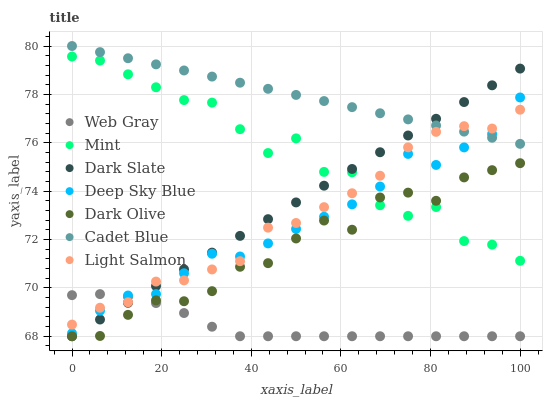Does Web Gray have the minimum area under the curve?
Answer yes or no. Yes. Does Cadet Blue have the maximum area under the curve?
Answer yes or no. Yes. Does Dark Olive have the minimum area under the curve?
Answer yes or no. No. Does Dark Olive have the maximum area under the curve?
Answer yes or no. No. Is Dark Slate the smoothest?
Answer yes or no. Yes. Is Mint the roughest?
Answer yes or no. Yes. Is Cadet Blue the smoothest?
Answer yes or no. No. Is Cadet Blue the roughest?
Answer yes or no. No. Does Dark Olive have the lowest value?
Answer yes or no. Yes. Does Cadet Blue have the lowest value?
Answer yes or no. No. Does Cadet Blue have the highest value?
Answer yes or no. Yes. Does Dark Olive have the highest value?
Answer yes or no. No. Is Dark Olive less than Deep Sky Blue?
Answer yes or no. Yes. Is Deep Sky Blue greater than Dark Olive?
Answer yes or no. Yes. Does Mint intersect Light Salmon?
Answer yes or no. Yes. Is Mint less than Light Salmon?
Answer yes or no. No. Is Mint greater than Light Salmon?
Answer yes or no. No. Does Dark Olive intersect Deep Sky Blue?
Answer yes or no. No. 